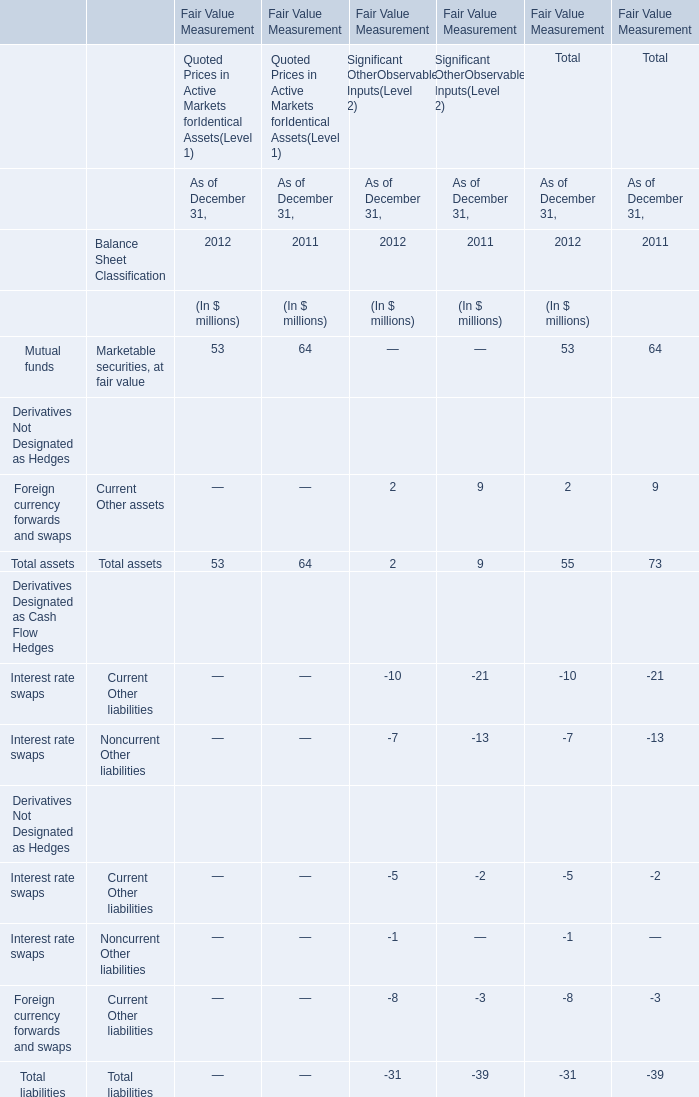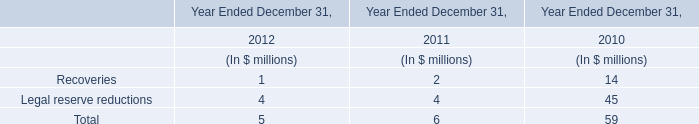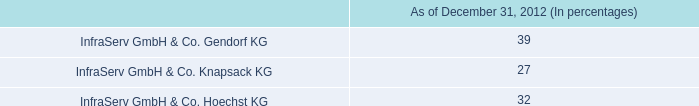What's the current growth rate of Total liabilities for Total? 
Computations: ((39 - 31) / 39)
Answer: 0.20513. 